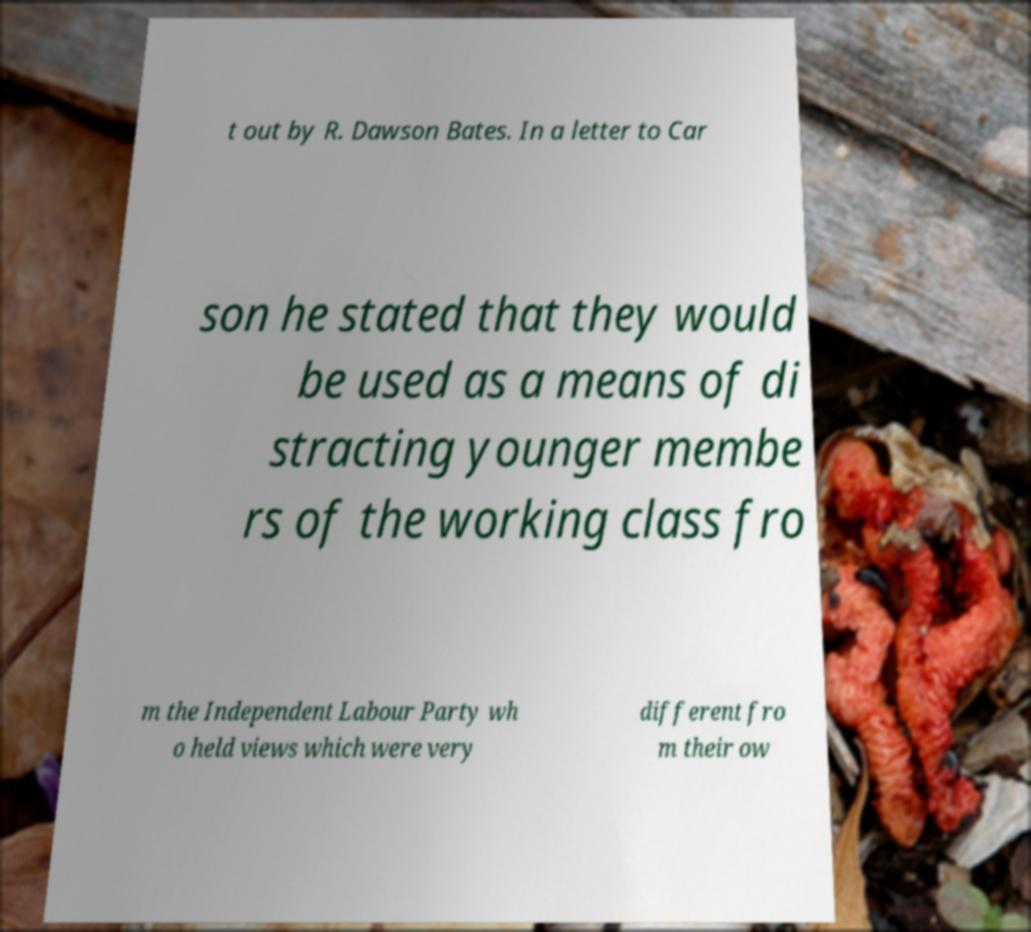Can you read and provide the text displayed in the image?This photo seems to have some interesting text. Can you extract and type it out for me? t out by R. Dawson Bates. In a letter to Car son he stated that they would be used as a means of di stracting younger membe rs of the working class fro m the Independent Labour Party wh o held views which were very different fro m their ow 